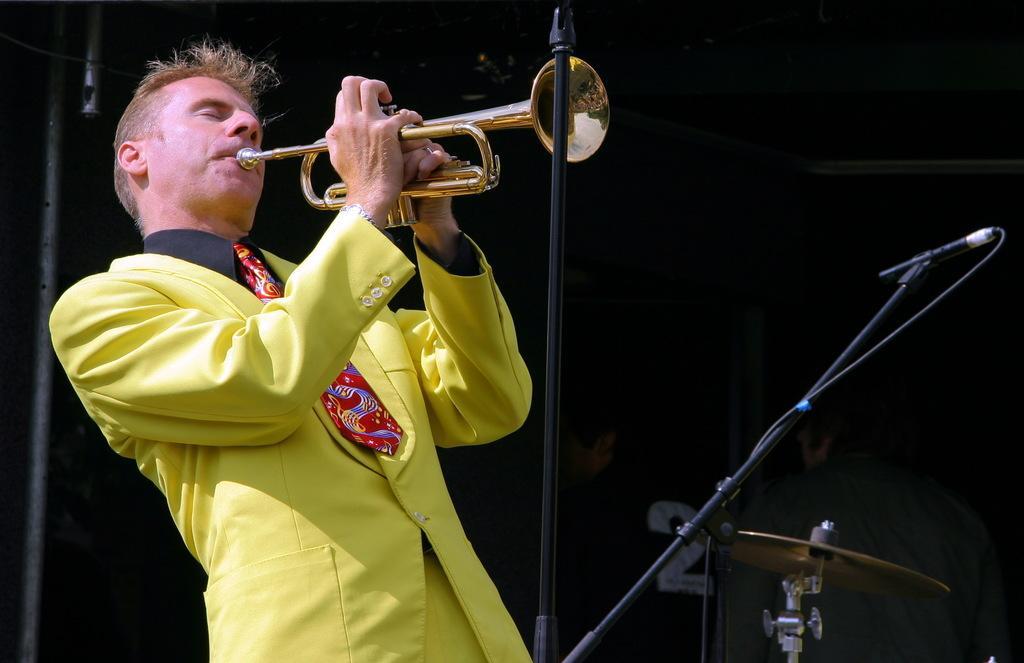How would you summarize this image in a sentence or two? In this picture we can see a man is standing and playing a trumpet, we can see a microphone and a cymbal on the right side, there is a dark background. 